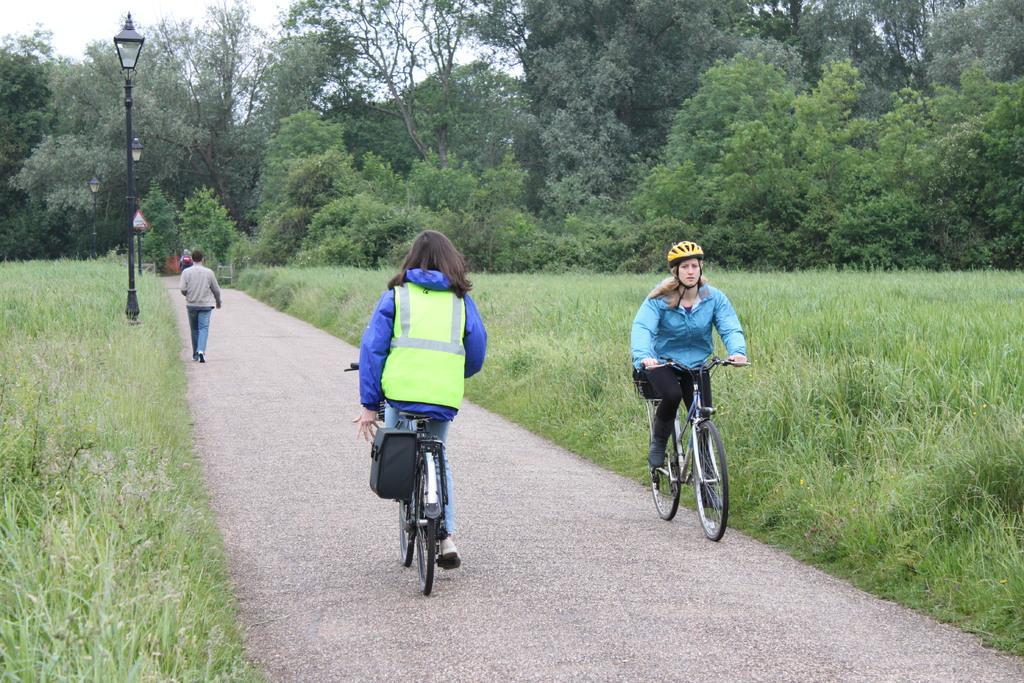Describe this image in one or two sentences. In this image there is a path on that path there are two women cycling and two persons are walking, on either side of the path there is grass and light poles, in the background there are trees. 